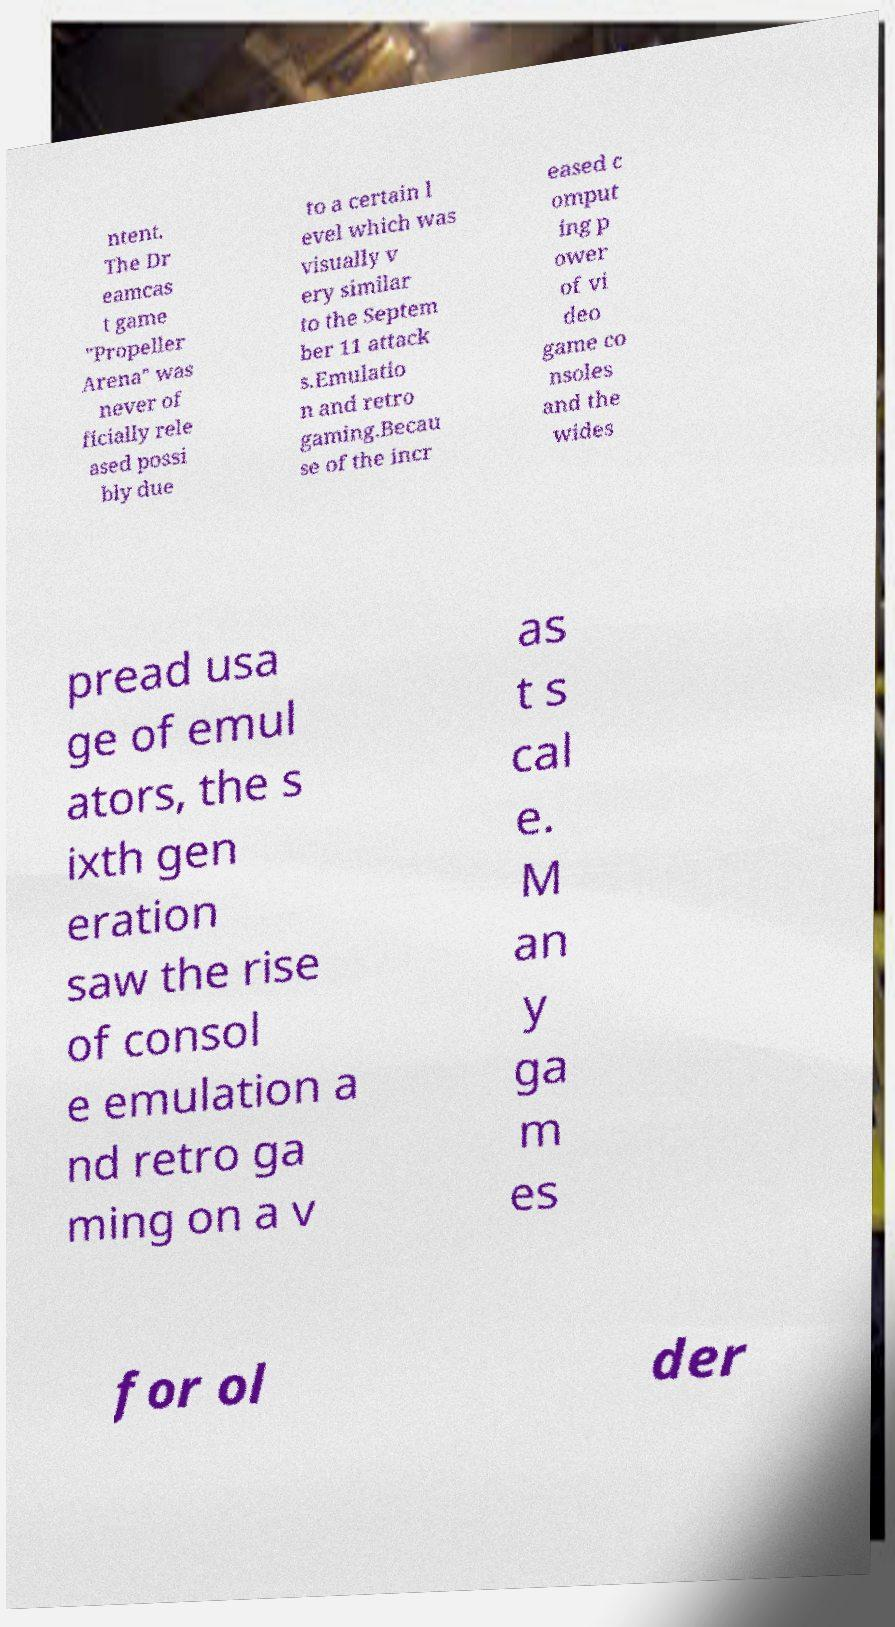What messages or text are displayed in this image? I need them in a readable, typed format. ntent. The Dr eamcas t game "Propeller Arena" was never of ficially rele ased possi bly due to a certain l evel which was visually v ery similar to the Septem ber 11 attack s.Emulatio n and retro gaming.Becau se of the incr eased c omput ing p ower of vi deo game co nsoles and the wides pread usa ge of emul ators, the s ixth gen eration saw the rise of consol e emulation a nd retro ga ming on a v as t s cal e. M an y ga m es for ol der 